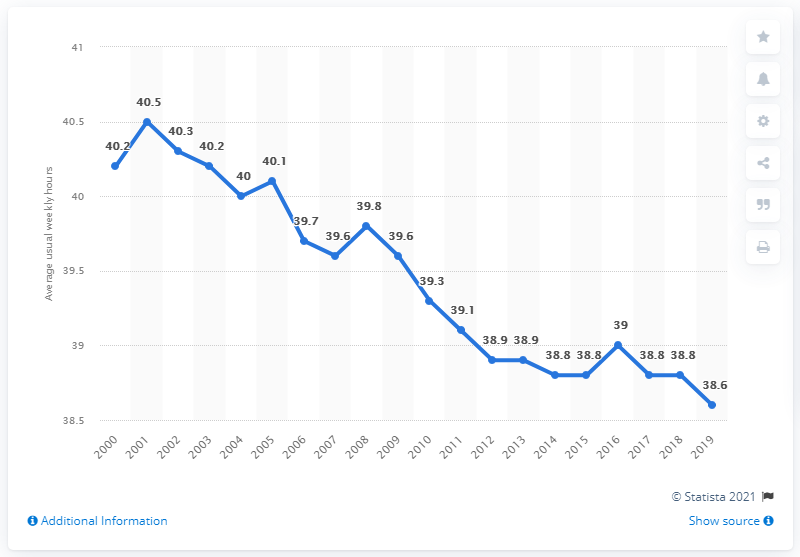Outline some significant characteristics in this image. Greece's weekly working hours in 2001 were 40.5 hours. In 2019, the average weekly hours worked in Greece was 38.6 hours. 